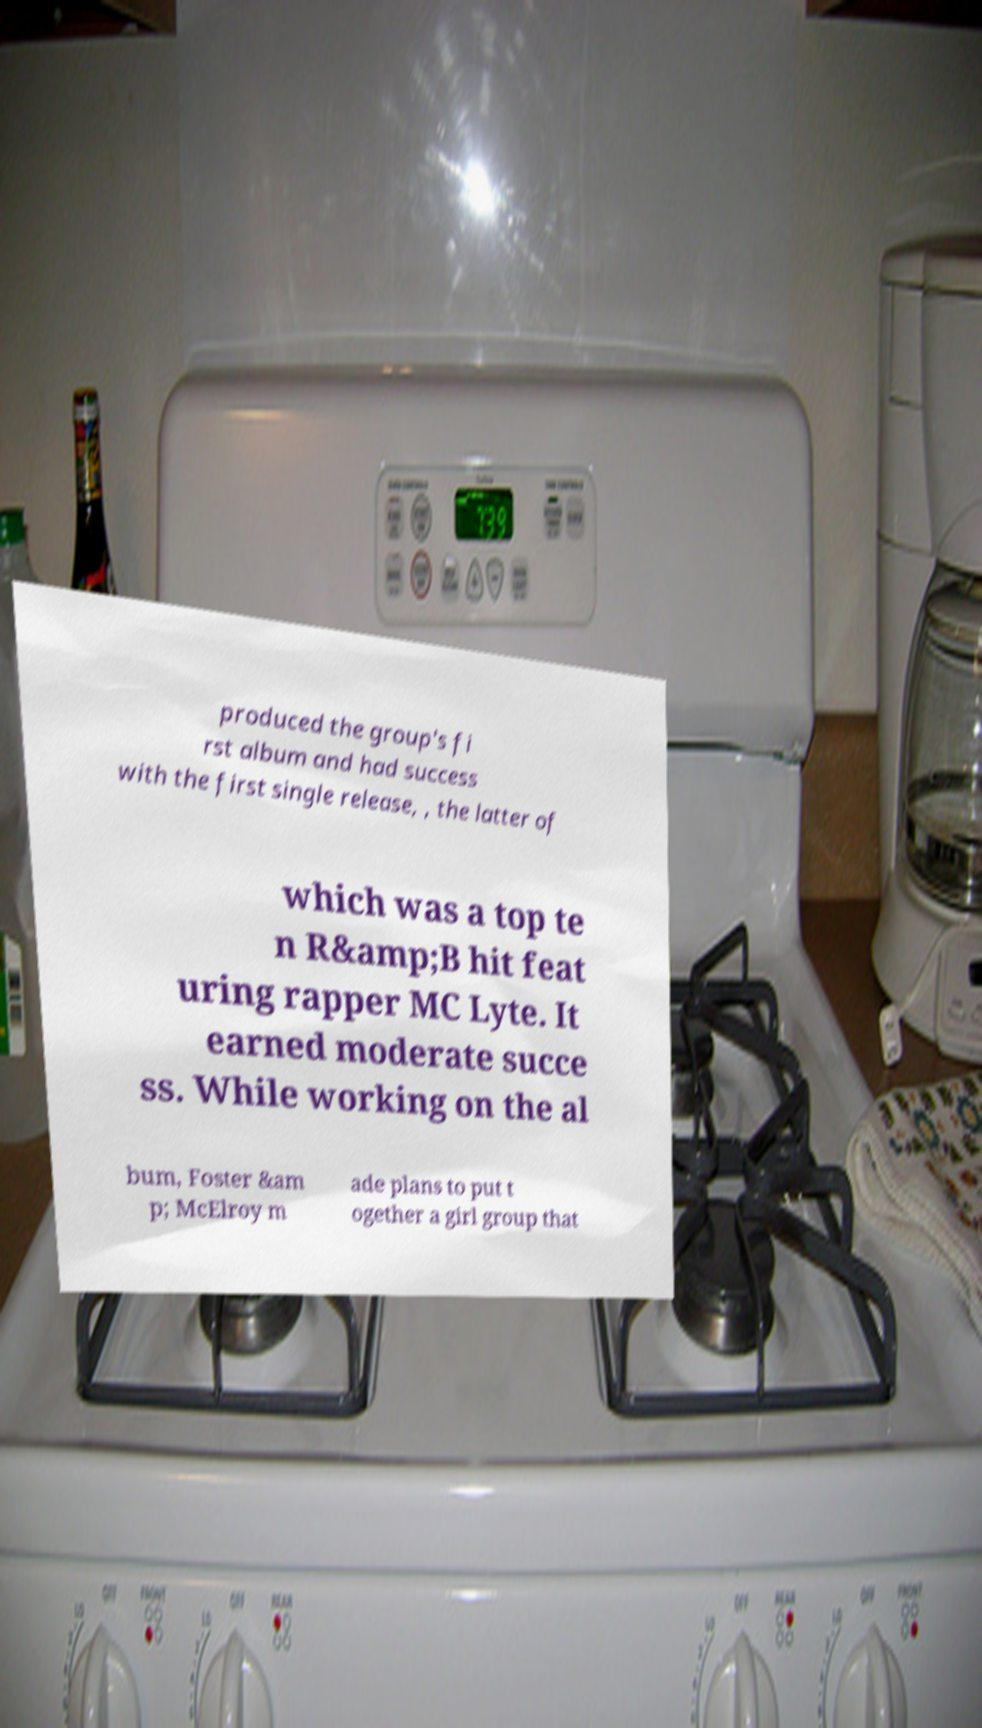What messages or text are displayed in this image? I need them in a readable, typed format. produced the group's fi rst album and had success with the first single release, , the latter of which was a top te n R&amp;B hit feat uring rapper MC Lyte. It earned moderate succe ss. While working on the al bum, Foster &am p; McElroy m ade plans to put t ogether a girl group that 